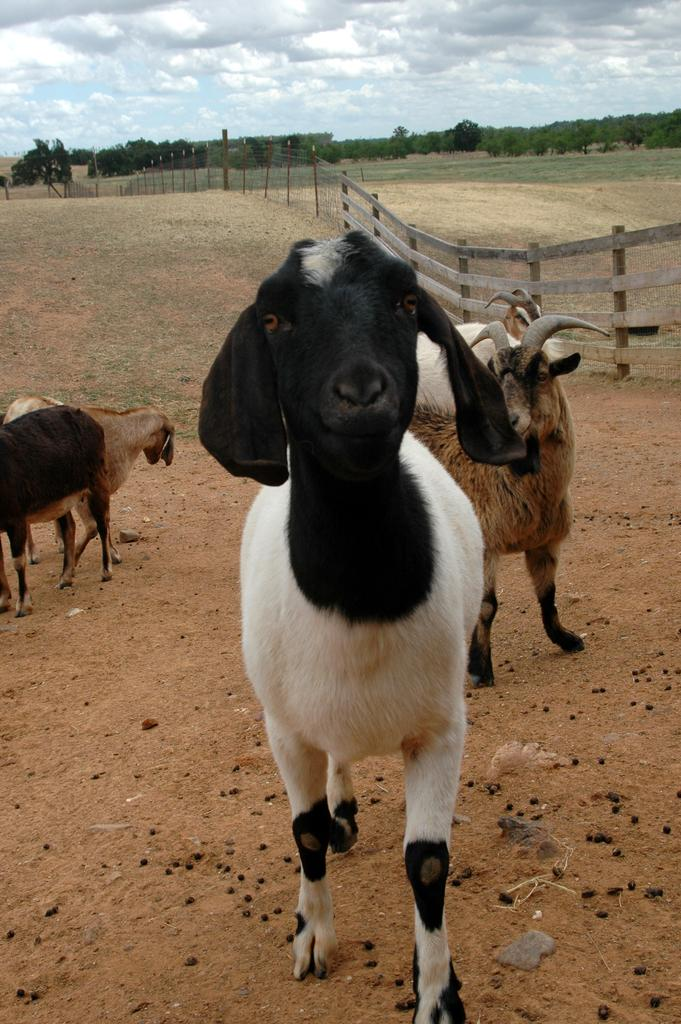What type of vegetation is present in the image? There are many trees in the image. How would you describe the sky in the image? The sky is cloudy in the image. What kind of barrier can be seen in the image? There is a fencing in the image. How many animals are visible in the image? There are few animals in the image. What is the terrain like in the image? There is a grassy land in the image. Can you tell me where the bridge is located in the image? There is no bridge present in the image. What type of wine is being served in the image? There is no wine present in the image. 